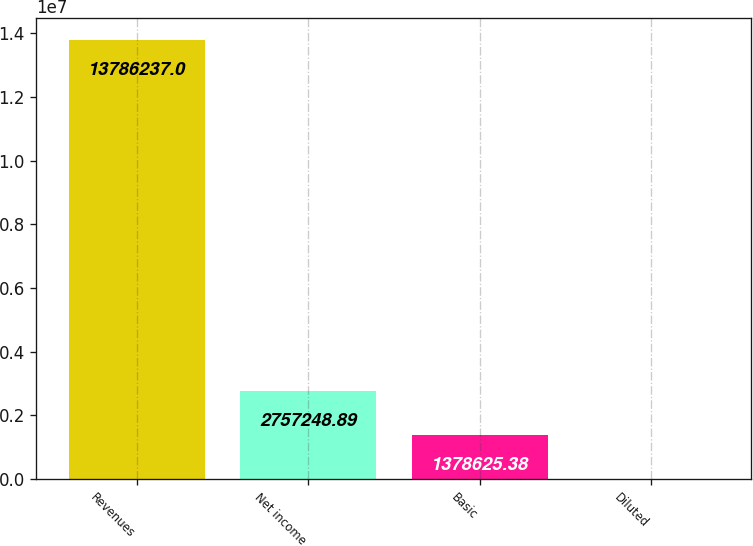Convert chart to OTSL. <chart><loc_0><loc_0><loc_500><loc_500><bar_chart><fcel>Revenues<fcel>Net income<fcel>Basic<fcel>Diluted<nl><fcel>1.37862e+07<fcel>2.75725e+06<fcel>1.37863e+06<fcel>1.87<nl></chart> 